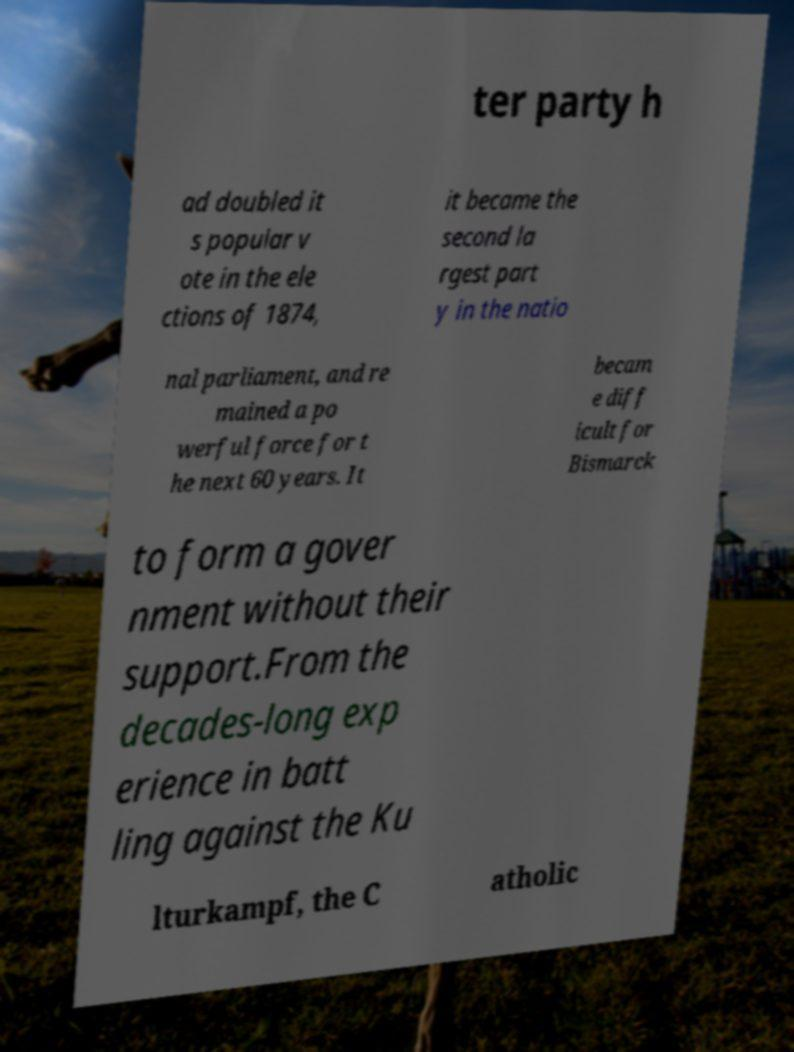What messages or text are displayed in this image? I need them in a readable, typed format. ter party h ad doubled it s popular v ote in the ele ctions of 1874, it became the second la rgest part y in the natio nal parliament, and re mained a po werful force for t he next 60 years. It becam e diff icult for Bismarck to form a gover nment without their support.From the decades-long exp erience in batt ling against the Ku lturkampf, the C atholic 